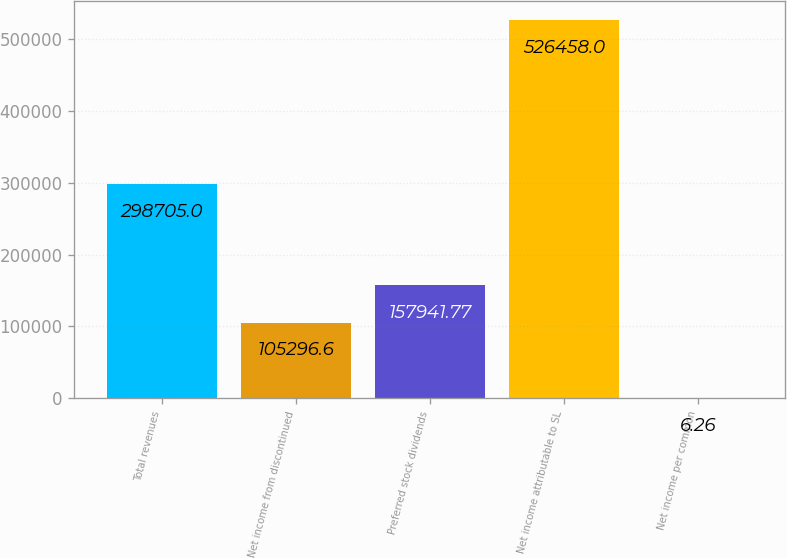Convert chart to OTSL. <chart><loc_0><loc_0><loc_500><loc_500><bar_chart><fcel>Total revenues<fcel>Net income from discontinued<fcel>Preferred stock dividends<fcel>Net income attributable to SL<fcel>Net income per common<nl><fcel>298705<fcel>105297<fcel>157942<fcel>526458<fcel>6.26<nl></chart> 